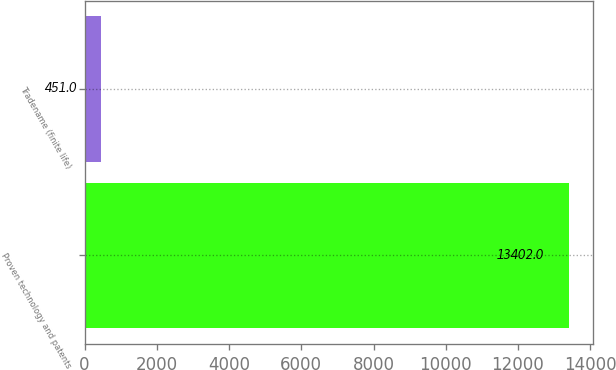<chart> <loc_0><loc_0><loc_500><loc_500><bar_chart><fcel>Proven technology and patents<fcel>Tradename (finite life)<nl><fcel>13402<fcel>451<nl></chart> 